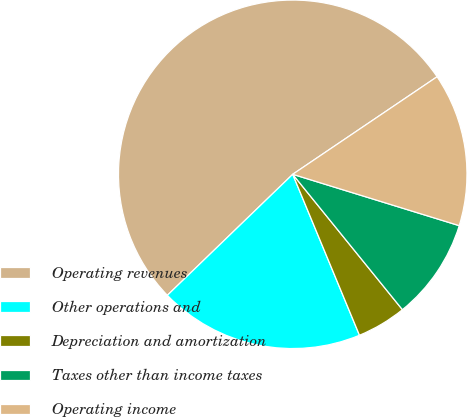Convert chart. <chart><loc_0><loc_0><loc_500><loc_500><pie_chart><fcel>Operating revenues<fcel>Other operations and<fcel>Depreciation and amortization<fcel>Taxes other than income taxes<fcel>Operating income<nl><fcel>52.76%<fcel>19.04%<fcel>4.58%<fcel>9.4%<fcel>14.22%<nl></chart> 